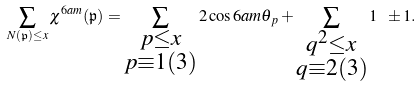<formula> <loc_0><loc_0><loc_500><loc_500>\sum _ { N ( \mathfrak { p } ) \leq x } \chi ^ { 6 a m } ( \mathfrak { p } ) = \sum _ { \substack { p \leq x \\ p \equiv 1 ( 3 ) } } 2 \cos 6 a m \theta _ { p } + \sum _ { \substack { q ^ { 2 } \leq x \\ q \equiv 2 ( 3 ) } } 1 \ \pm 1 .</formula> 